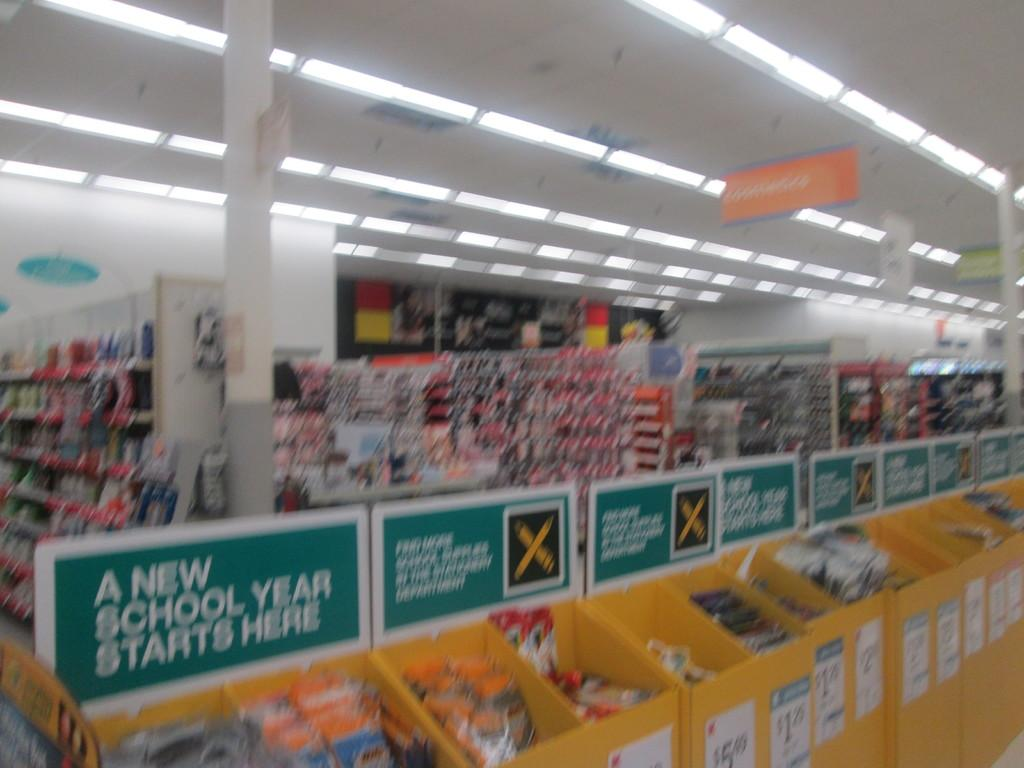<image>
Render a clear and concise summary of the photo. A store with a large bin of school supplies labeled "A New School Year Starts Here" 